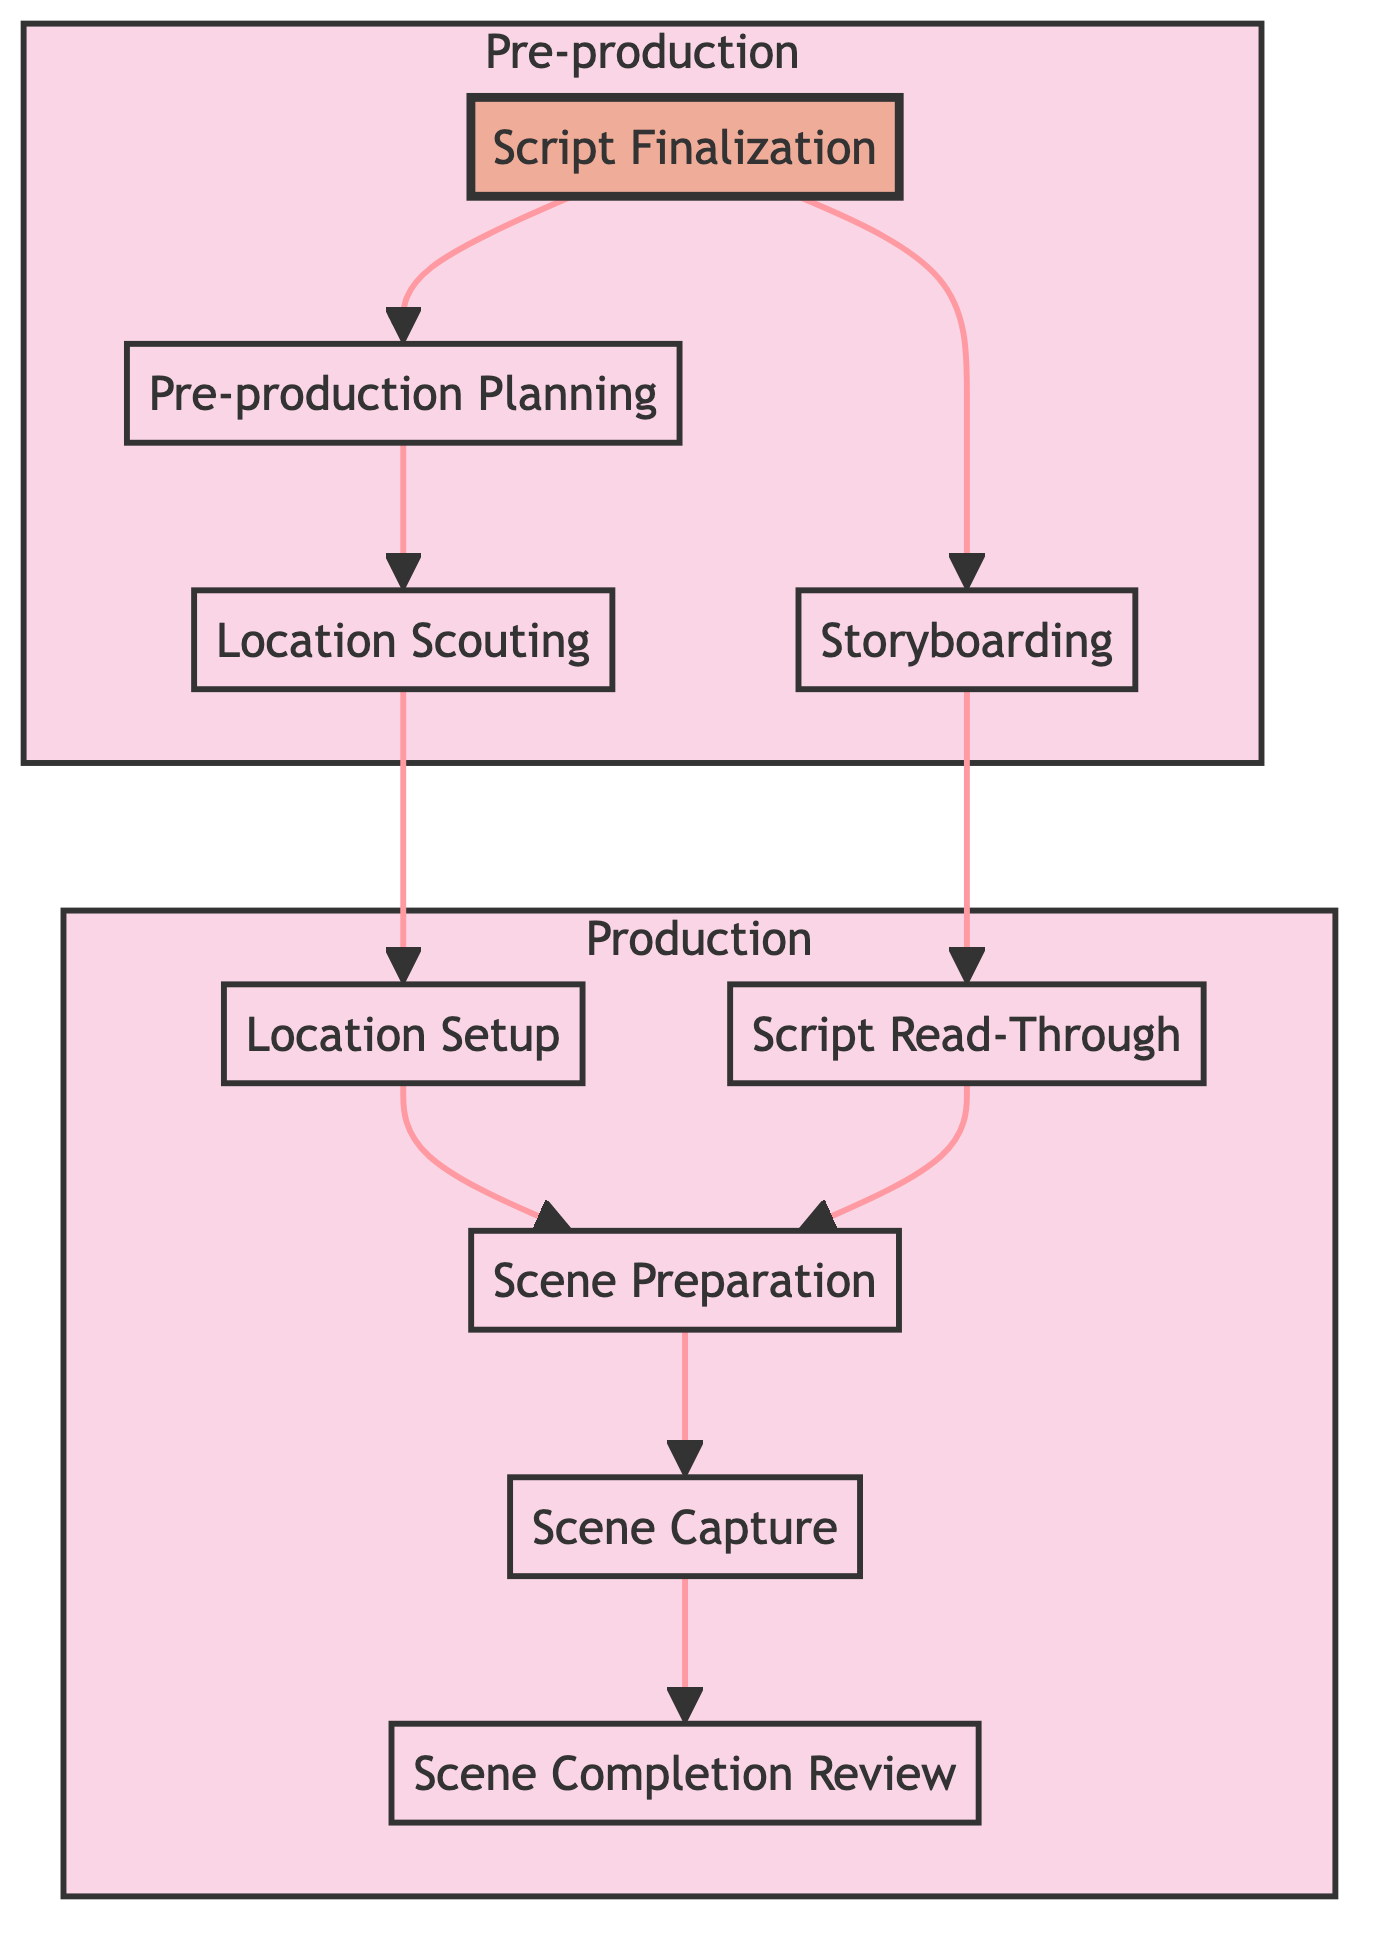What is the final step in the filming schedule? The final step shown in the diagram is "Scene Completion Review," which is the last node in the flow. It indicates that after scenes are captured, they are reviewed for quality.
Answer: Scene Completion Review How many nodes are there in total? By counting all the nodes represented in the diagram, there are a total of eight distinct nodes listed.
Answer: Eight Which task directly precedes "Scene Capture"? The node that directly leads into "Scene Capture" is "Scene Preparation," which indicates that scene preparation must occur first.
Answer: Scene Preparation What is the primary purpose of "Location Scouting"? "Location Scouting" is primarily about finding appropriate locations for filming scenes, as indicated in the description of that node.
Answer: Finding appropriate locations Which two tasks must be completed before "Scene Preparation"? "Location Setup" and "Script Read-Through" both need to be finished before moving on to "Scene Preparation," as they are dependencies.
Answer: Location Setup, Script Read-Through Which two tasks are dependent on "Script Finalization"? The tasks that depend on "Script Finalization" are "Storyboarding" and "Pre-production Planning," as seen from the connections to those nodes.
Answer: Storyboarding, Pre-production Planning How many pre-production tasks are there in the diagram? There are four tasks tagged as pre-production tasks: "Location Scouting," "Storyboarding," "Pre-production Planning," and "Script Finalization."
Answer: Four What is the first task in the shooting sequence? The first task outlined that needs to happen to kick off the filming process is "Scene Preparation," as it is the first step leading to filming.
Answer: Scene Preparation Which task encompasses the review of the script? The task that includes reviewing the script with all department heads and talent is "Script Read-Through," which highlights the collaborative nature of the process.
Answer: Script Read-Through 